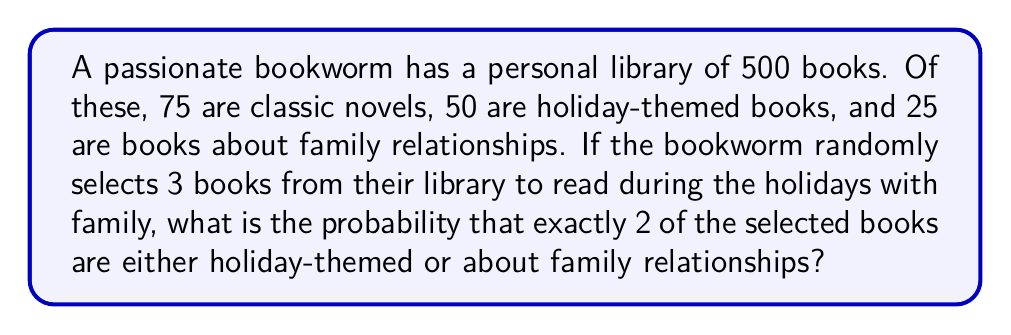Help me with this question. Let's approach this step-by-step:

1) First, we need to calculate the total number of ways to select 3 books from 500. This is given by the combination formula:

   $$\binom{500}{3} = \frac{500!}{3!(500-3)!} = \frac{500!}{3!497!} = 20,708,500$$

2) Now, we need to calculate the number of ways to select exactly 2 books that are either holiday-themed or about family relationships, and 1 book that is not from these categories.

3) The total number of holiday-themed or family relationship books is:
   $50 + 25 = 75$

4) The number of ways to select 2 books from these 75 books is:

   $$\binom{75}{2} = \frac{75!}{2!73!} = 2,775$$

5) The remaining books (not holiday-themed or about family) are:
   $500 - 75 = 425$

6) We need to select 1 book from these 425 books, which can be done in $\binom{425}{1} = 425$ ways.

7) By the multiplication principle, the total number of favorable outcomes is:

   $$2,775 \times 425 = 1,179,375$$

8) The probability is then:

   $$P(\text{exactly 2 holiday/family books}) = \frac{1,179,375}{20,708,500} = \frac{2,359}{41,417} \approx 0.0569$$
Answer: The probability is $\frac{2,359}{41,417}$ or approximately 0.0569 (5.69%). 